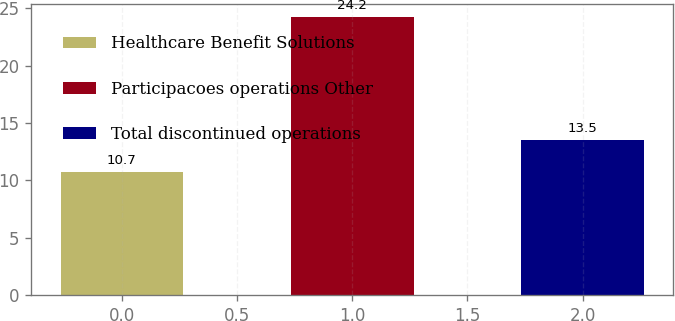Convert chart to OTSL. <chart><loc_0><loc_0><loc_500><loc_500><bar_chart><fcel>Healthcare Benefit Solutions<fcel>Participacoes operations Other<fcel>Total discontinued operations<nl><fcel>10.7<fcel>24.2<fcel>13.5<nl></chart> 